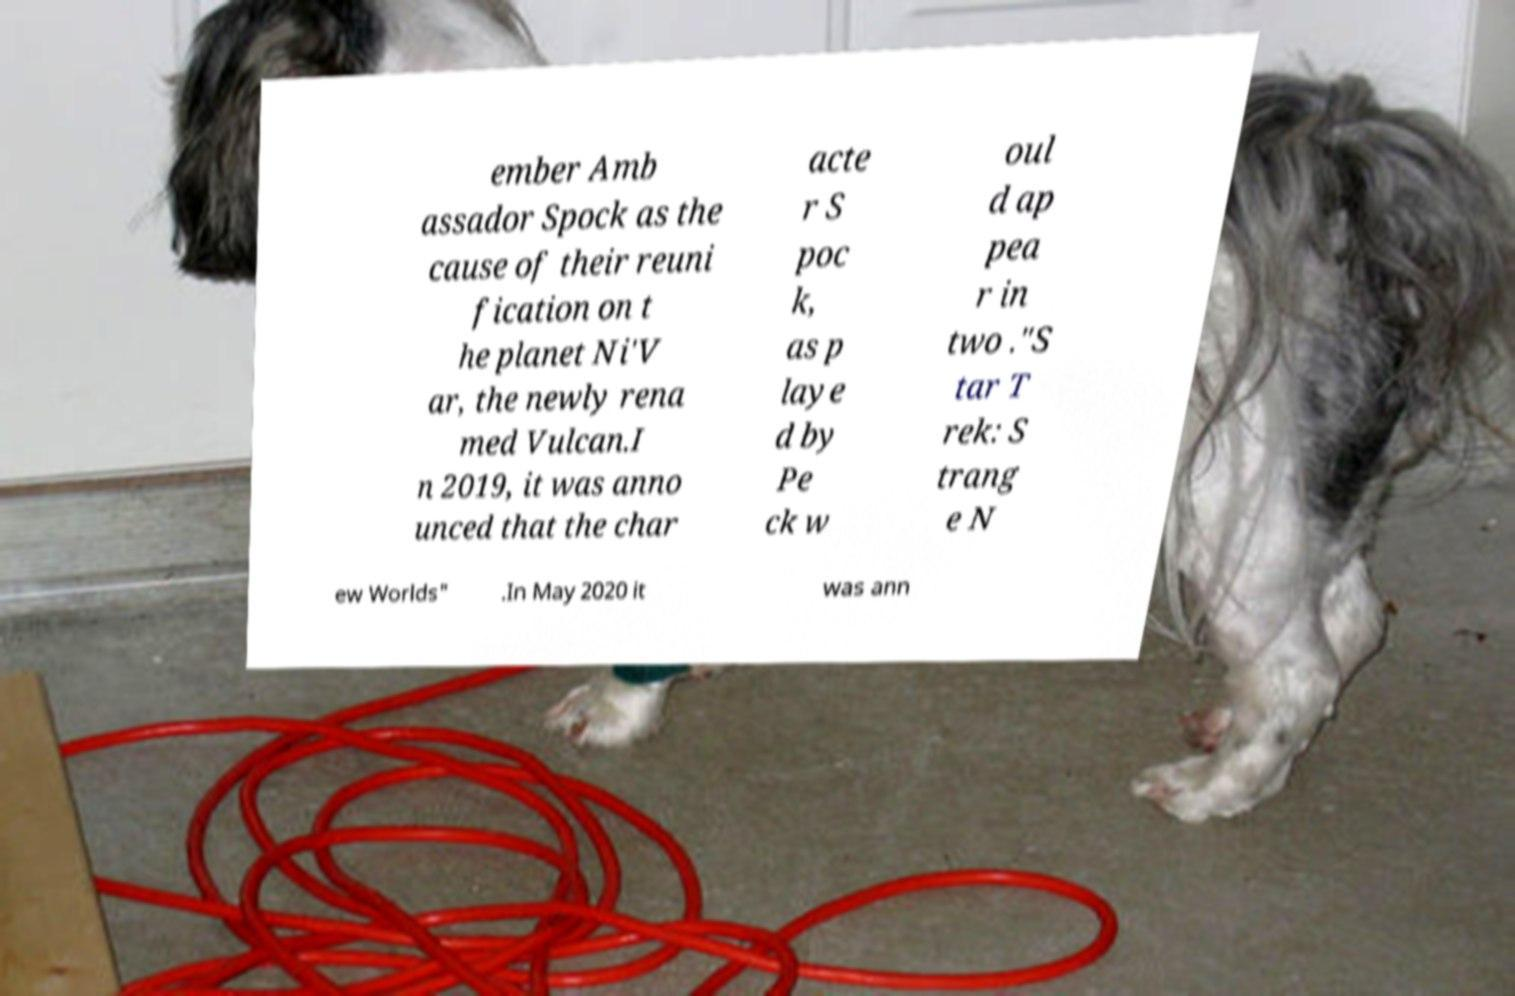Could you extract and type out the text from this image? ember Amb assador Spock as the cause of their reuni fication on t he planet Ni'V ar, the newly rena med Vulcan.I n 2019, it was anno unced that the char acte r S poc k, as p laye d by Pe ck w oul d ap pea r in two ."S tar T rek: S trang e N ew Worlds" .In May 2020 it was ann 